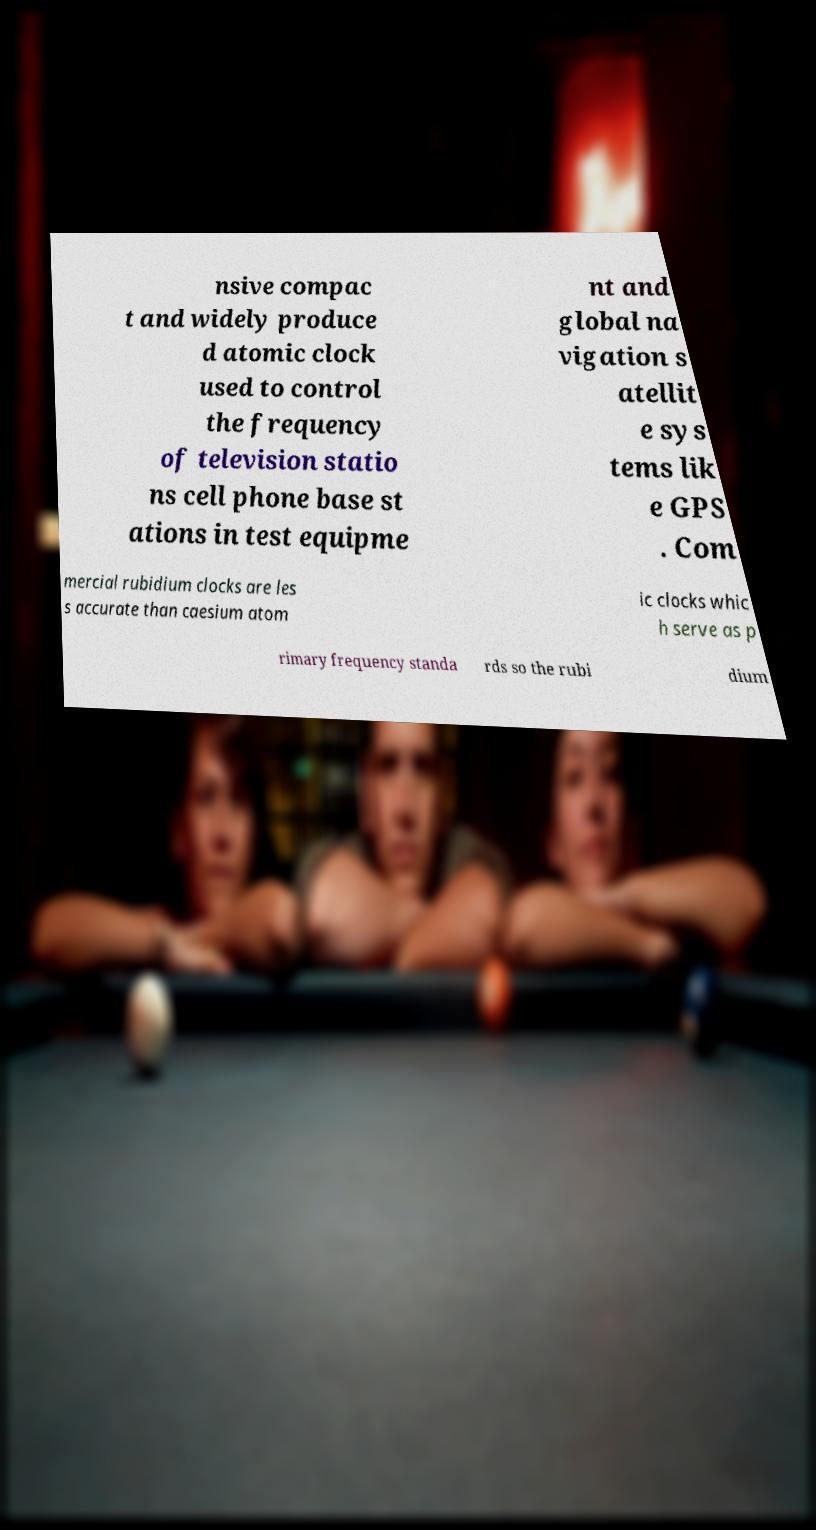Please read and relay the text visible in this image. What does it say? nsive compac t and widely produce d atomic clock used to control the frequency of television statio ns cell phone base st ations in test equipme nt and global na vigation s atellit e sys tems lik e GPS . Com mercial rubidium clocks are les s accurate than caesium atom ic clocks whic h serve as p rimary frequency standa rds so the rubi dium 